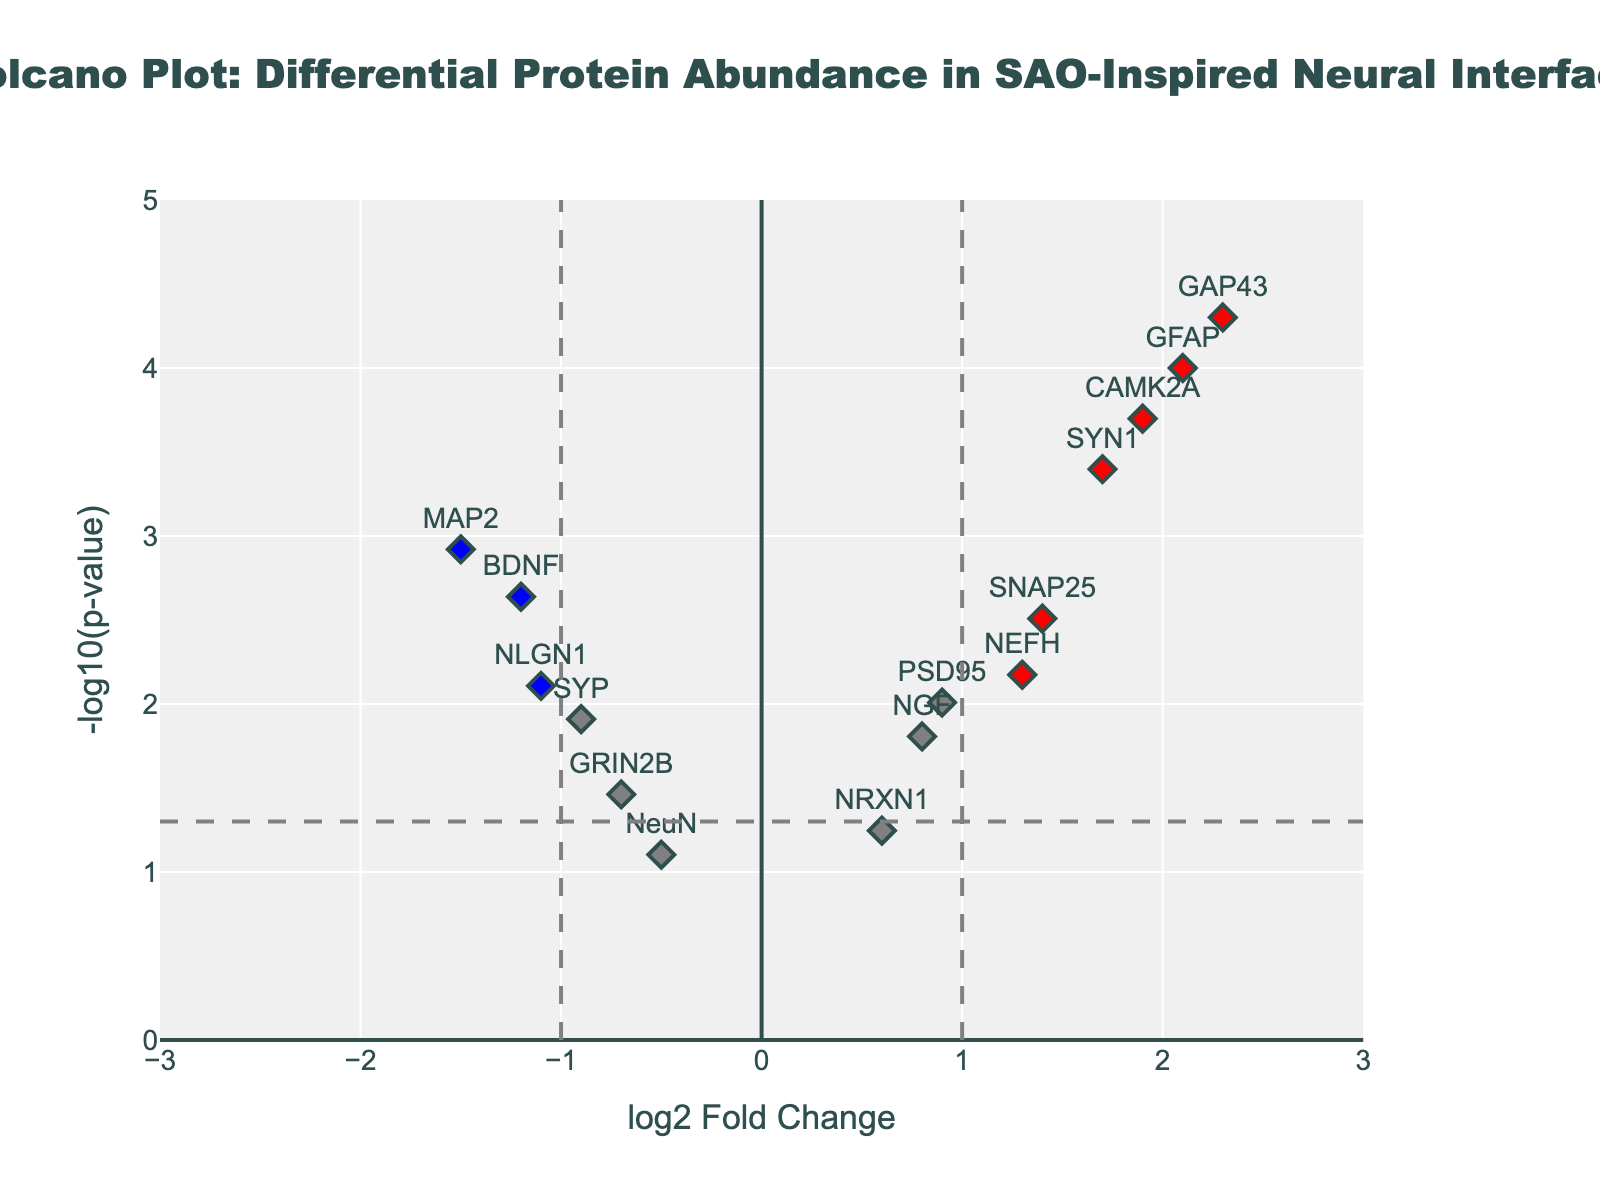How many proteins are classified as significantly upregulated? To classify proteins as significantly upregulated, we look for those with a log2FoldChange greater than 1 and a p-value less than 0.05. The red points on the volcano plot represent these proteins. From the figure, we see that there are 5 such proteins.
Answer: 5 Which proteins are significantly downregulated? Proteins that are significantly downregulated have a log2FoldChange less than -1 and a p-value less than 0.05. The blue points on the volcano plot indicate these proteins. From the figure, the significantly downregulated proteins are BDNF, MAP2, and NLGN1.
Answer: BDNF, MAP2, NLGN1 What are the axes' titles of the volcano plot? The x-axis title represents "log2 Fold Change," indicating the change in protein abundance on a logarithmic scale, while the y-axis title represents "-log10(p-value)," indicating the significance level of the protein abundance changes.
Answer: log2 Fold Change, -log10(p-value) Which protein has the highest log2 Fold Change in the figure? To identify the protein with the highest log2 Fold Change, locate the farthest point to the right on the x-axis. The protein with the highest log2 Fold Change is GAP43, with a value of 2.3.
Answer: GAP43 Compare the log2 Fold Change of SYN1 and BDNF. Which one is higher? To compare their log2 Fold Change, locate SYN1 and BDNF points on the x-axis. SYN1 has a log2 Fold Change of 1.7, while BDNF has -1.2. SYN1’s log2 Fold Change is higher than BDNF’s.
Answer: SYN1 What is the p-value threshold for significance on the plot? The horizontal dashed line in the plot shows the p-value threshold for significance. The y-axis value of this line is -log10(0.05), which equals approximately 1.301.
Answer: 0.05 How many proteins have a log2 Fold Change between -0.5 and 0.5? Proteins with a log2 Fold Change between -0.5 and 0.5 can be identified by looking at the points along that range on the x-axis. In this range, the NeuN point is the only one, making it just 1 protein.
Answer: 1 Which protein is closer to the p-value threshold but does not exceed it? The protein just below the horizontal dashed line indicating the significance threshold is NeuN, as its y-axis value (significance level) is very close to the threshold line around 1.301.
Answer: NeuN Which vertically aligned dashed line represents the log2 Fold Change threshold for upregulation? The vertical dashed line towards the right side of the plot represents the log2 Fold Change threshold for upregulation, which is set at a value of 1 on the x-axis.
Answer: 1 